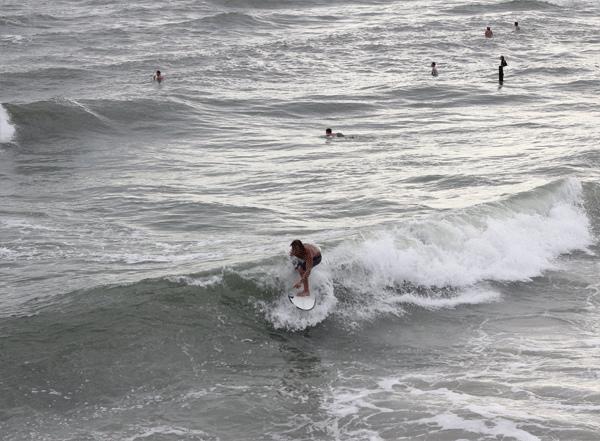Is there a storm coming in?
Concise answer only. Yes. How many people in the water?
Quick response, please. 7. Is the surfing man wearing a shirt?
Short answer required. No. How many surfers are in the picture?
Concise answer only. 1. 